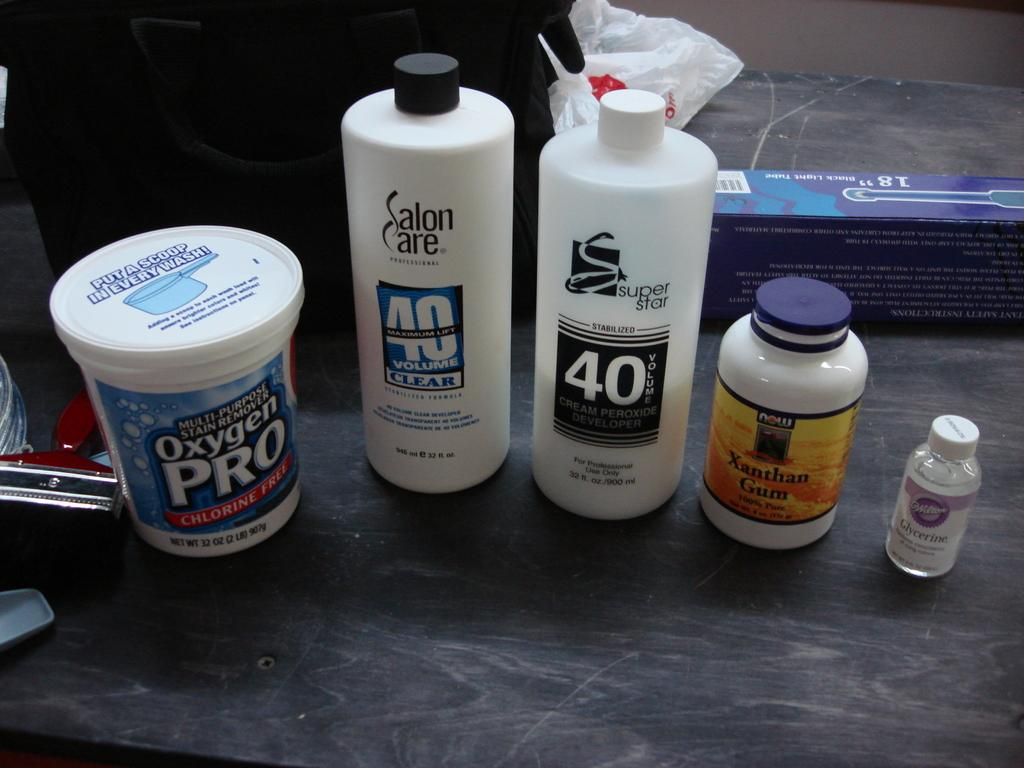<image>
Render a clear and concise summary of the photo. several bottles in a row, including a bottle of oxygen pro detergent 